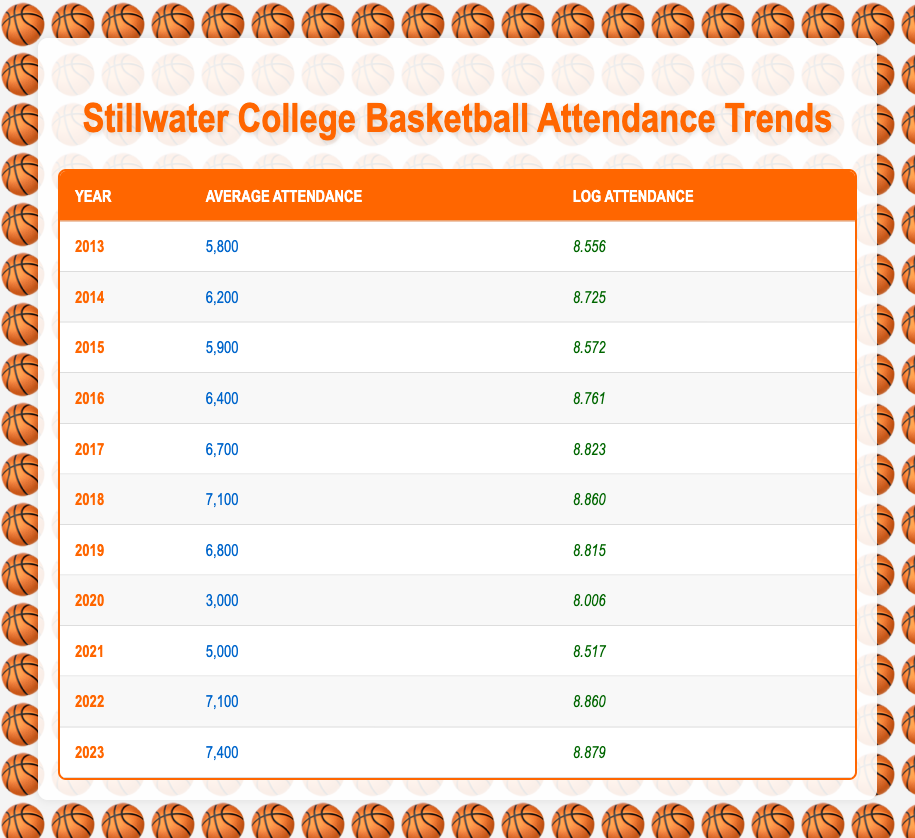What was the average attendance for the year 2016? The table shows that for the year 2016, the average attendance recorded was 6,400.
Answer: 6,400 In which year did the average attendance first exceed 7,000? By examining the average attendance column, we see the first instance where it exceeds 7,000 is in the year 2018, with an average attendance of 7,100.
Answer: 2018 What is the difference in average attendance between 2023 and 2019? The average attendance for 2023 is 7,400, and for 2019 it is 6,800. The difference is 7,400 - 6,800 = 600.
Answer: 600 Did the average attendance ever drop below 4,000 in the last decade? The lowest average attendance recorded was in 2020, which was 3,000, therefore the statement is true.
Answer: Yes Calculate the average attendance from 2013 to 2023. To find the average, we sum the average attendances from each year: (5800 + 6200 + 5900 + 6400 + 6700 + 7100 + 6800 + 3000 + 5000 + 7100 + 7400) = 58,600. There are 11 years, so the average is 58,600 / 11 = 5,327.27.
Answer: 5,327.27 How many years had an average attendance greater than 6,500? From the table, we can see that the years with averages above 6,500 are 2017, 2018, 2019, 2022, and 2023, totaling 5 years.
Answer: 5 What is the log attendance value for the year with the highest average attendance? The highest average attendance recorded is 7,400 in the year 2023. Referring to the log attendance, the value is 8.879.
Answer: 8.879 Was the average attendance in 2021 higher than 2020? The average attendance in 2021 was 5,000 and in 2020 it was 3,000. Since 5,000 is greater than 3,000, the statement is true.
Answer: Yes What trend can you observe from the attendance over the years? Observing the data, there is a general upward trend in attendance from 2013 to 2019, with a decline in 2020, then a recovery in the following years, peaking in 2023.
Answer: General upward trend with recovery 